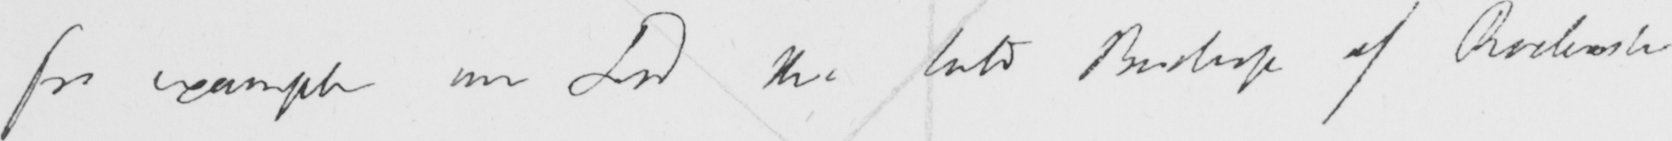Can you read and transcribe this handwriting? for example our Lord the late Bishop of Rochester 